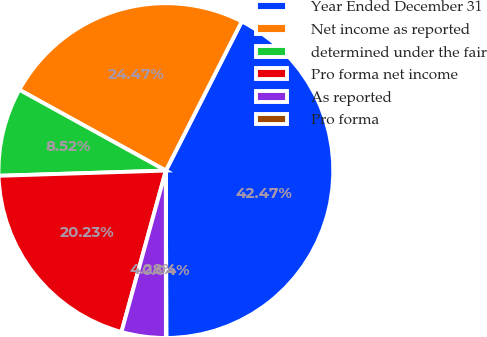<chart> <loc_0><loc_0><loc_500><loc_500><pie_chart><fcel>Year Ended December 31<fcel>Net income as reported<fcel>determined under the fair<fcel>Pro forma net income<fcel>As reported<fcel>Pro forma<nl><fcel>42.47%<fcel>24.47%<fcel>8.52%<fcel>20.23%<fcel>4.28%<fcel>0.04%<nl></chart> 